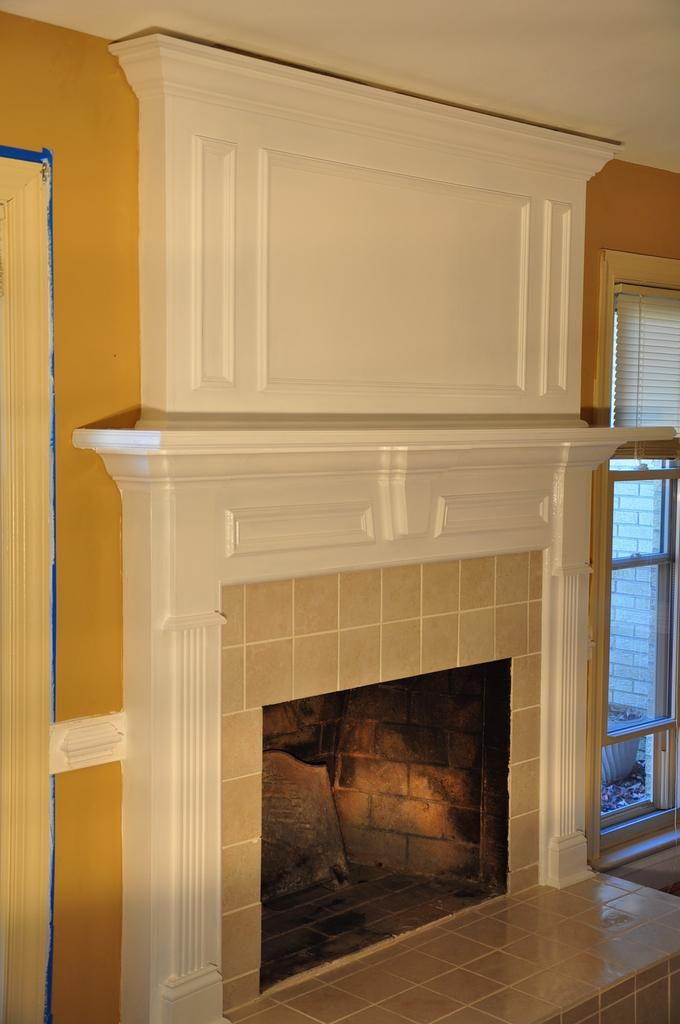Where was the image taken? The image was taken in a room. What is the main feature in the center of the image? There is a fireplace in the center of the image. What can be seen on the right side of the image? There is a window on the right side of the image. What is associated with the window? There is a curtain associated with the window. What else can be seen in the image? There is a wall visible in the image. How many dimes are visible on the fireplace mantle in the image? There are no dimes visible on the fireplace mantle in the image. What type of mailbox is located near the window in the image? There is no mailbox present in the image. 